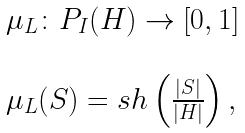Convert formula to latex. <formula><loc_0><loc_0><loc_500><loc_500>\begin{array} { l l } \mu _ { L } \colon P _ { I } ( H ) \rightarrow [ 0 , 1 ] \\ \\ \mu _ { L } ( S ) = s h \left ( \frac { | S | } { | H | } \right ) , \end{array}</formula> 